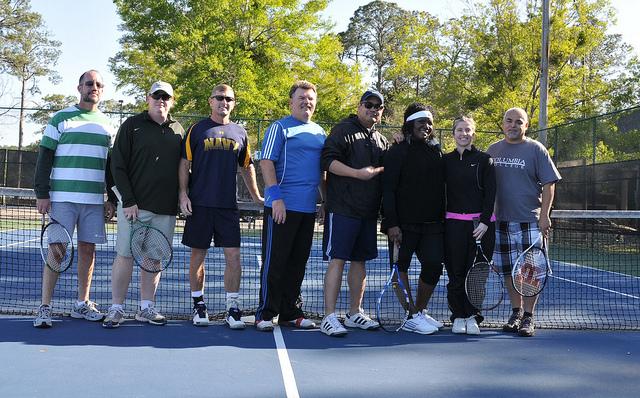How many boys are wearing glasses?
Keep it brief. 3. Are they all wearing sneakers?
Keep it brief. Yes. Is he holding a racket?
Be succinct. Yes. Are these people close friends?
Write a very short answer. Yes. What sport are the people going to play?
Short answer required. Tennis. 